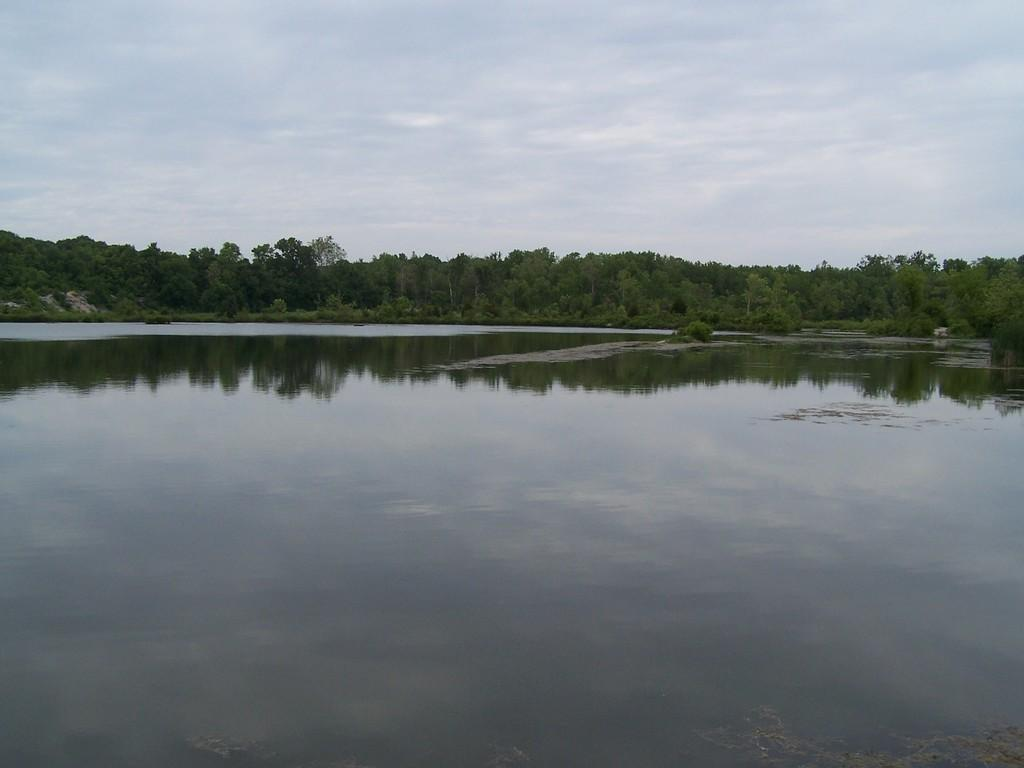What type of body of water is present in the image? There is a lake in the image. What type of vegetation can be seen in the image? There are trees in the image. What is visible in the background of the image? The sky is visible in the background of the image. What type of yam is being used as a prop in the image? There is no yam present in the image. How many knees are visible in the image? There are no knees visible in the image. 